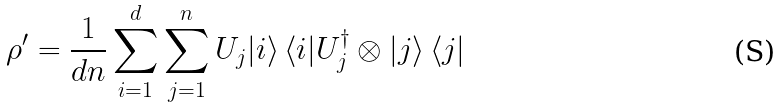<formula> <loc_0><loc_0><loc_500><loc_500>\rho ^ { \prime } = \frac { 1 } { d n } \sum _ { i = 1 } ^ { d } \sum _ { j = 1 } ^ { n } U _ { j } | i \rangle \, \langle i | U _ { j } ^ { \dag } \otimes | j \rangle \, \langle j |</formula> 